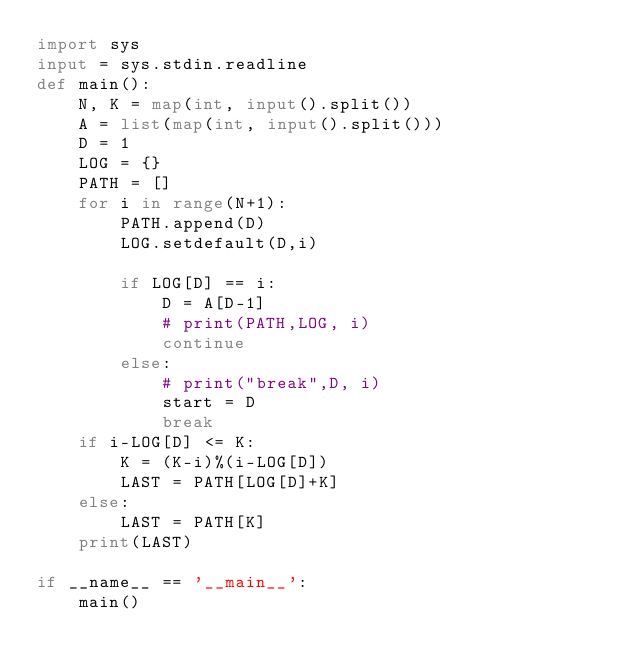<code> <loc_0><loc_0><loc_500><loc_500><_Python_>import sys
input = sys.stdin.readline
def main():
    N, K = map(int, input().split())
    A = list(map(int, input().split()))
    D = 1
    LOG = {}
    PATH = []
    for i in range(N+1):
        PATH.append(D)
        LOG.setdefault(D,i)

        if LOG[D] == i:
            D = A[D-1]
            # print(PATH,LOG, i)
            continue
        else:
            # print("break",D, i)
            start = D
            break
    if i-LOG[D] <= K:
        K = (K-i)%(i-LOG[D])
        LAST = PATH[LOG[D]+K]
    else:
        LAST = PATH[K]
    print(LAST)

if __name__ == '__main__':
    main()</code> 